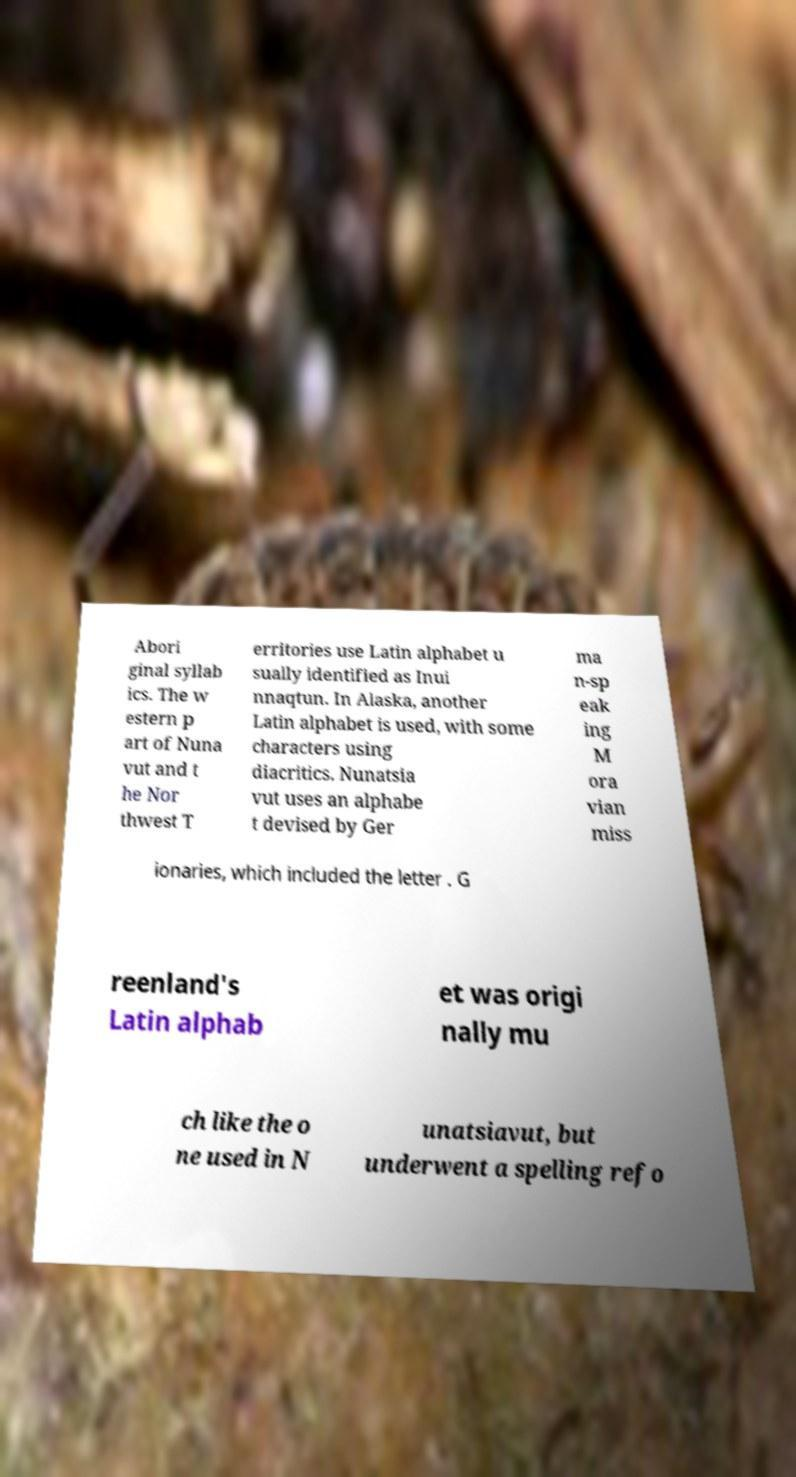I need the written content from this picture converted into text. Can you do that? Abori ginal syllab ics. The w estern p art of Nuna vut and t he Nor thwest T erritories use Latin alphabet u sually identified as Inui nnaqtun. In Alaska, another Latin alphabet is used, with some characters using diacritics. Nunatsia vut uses an alphabe t devised by Ger ma n-sp eak ing M ora vian miss ionaries, which included the letter . G reenland's Latin alphab et was origi nally mu ch like the o ne used in N unatsiavut, but underwent a spelling refo 